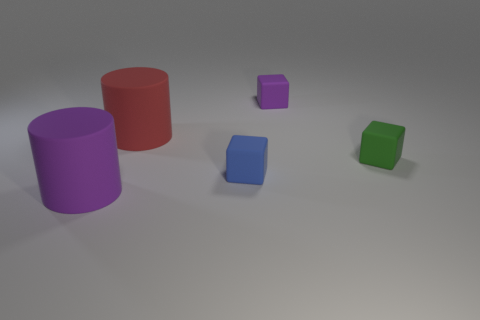Add 5 red things. How many objects exist? 10 Subtract all blocks. How many objects are left? 2 Subtract all red metal blocks. Subtract all purple cubes. How many objects are left? 4 Add 5 rubber cylinders. How many rubber cylinders are left? 7 Add 1 small blue objects. How many small blue objects exist? 2 Subtract 0 cyan cylinders. How many objects are left? 5 